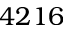<formula> <loc_0><loc_0><loc_500><loc_500>4 2 1 6</formula> 